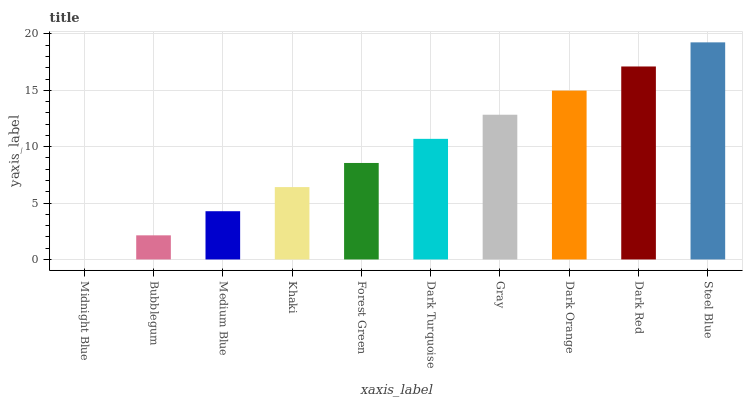Is Midnight Blue the minimum?
Answer yes or no. Yes. Is Steel Blue the maximum?
Answer yes or no. Yes. Is Bubblegum the minimum?
Answer yes or no. No. Is Bubblegum the maximum?
Answer yes or no. No. Is Bubblegum greater than Midnight Blue?
Answer yes or no. Yes. Is Midnight Blue less than Bubblegum?
Answer yes or no. Yes. Is Midnight Blue greater than Bubblegum?
Answer yes or no. No. Is Bubblegum less than Midnight Blue?
Answer yes or no. No. Is Dark Turquoise the high median?
Answer yes or no. Yes. Is Forest Green the low median?
Answer yes or no. Yes. Is Forest Green the high median?
Answer yes or no. No. Is Steel Blue the low median?
Answer yes or no. No. 